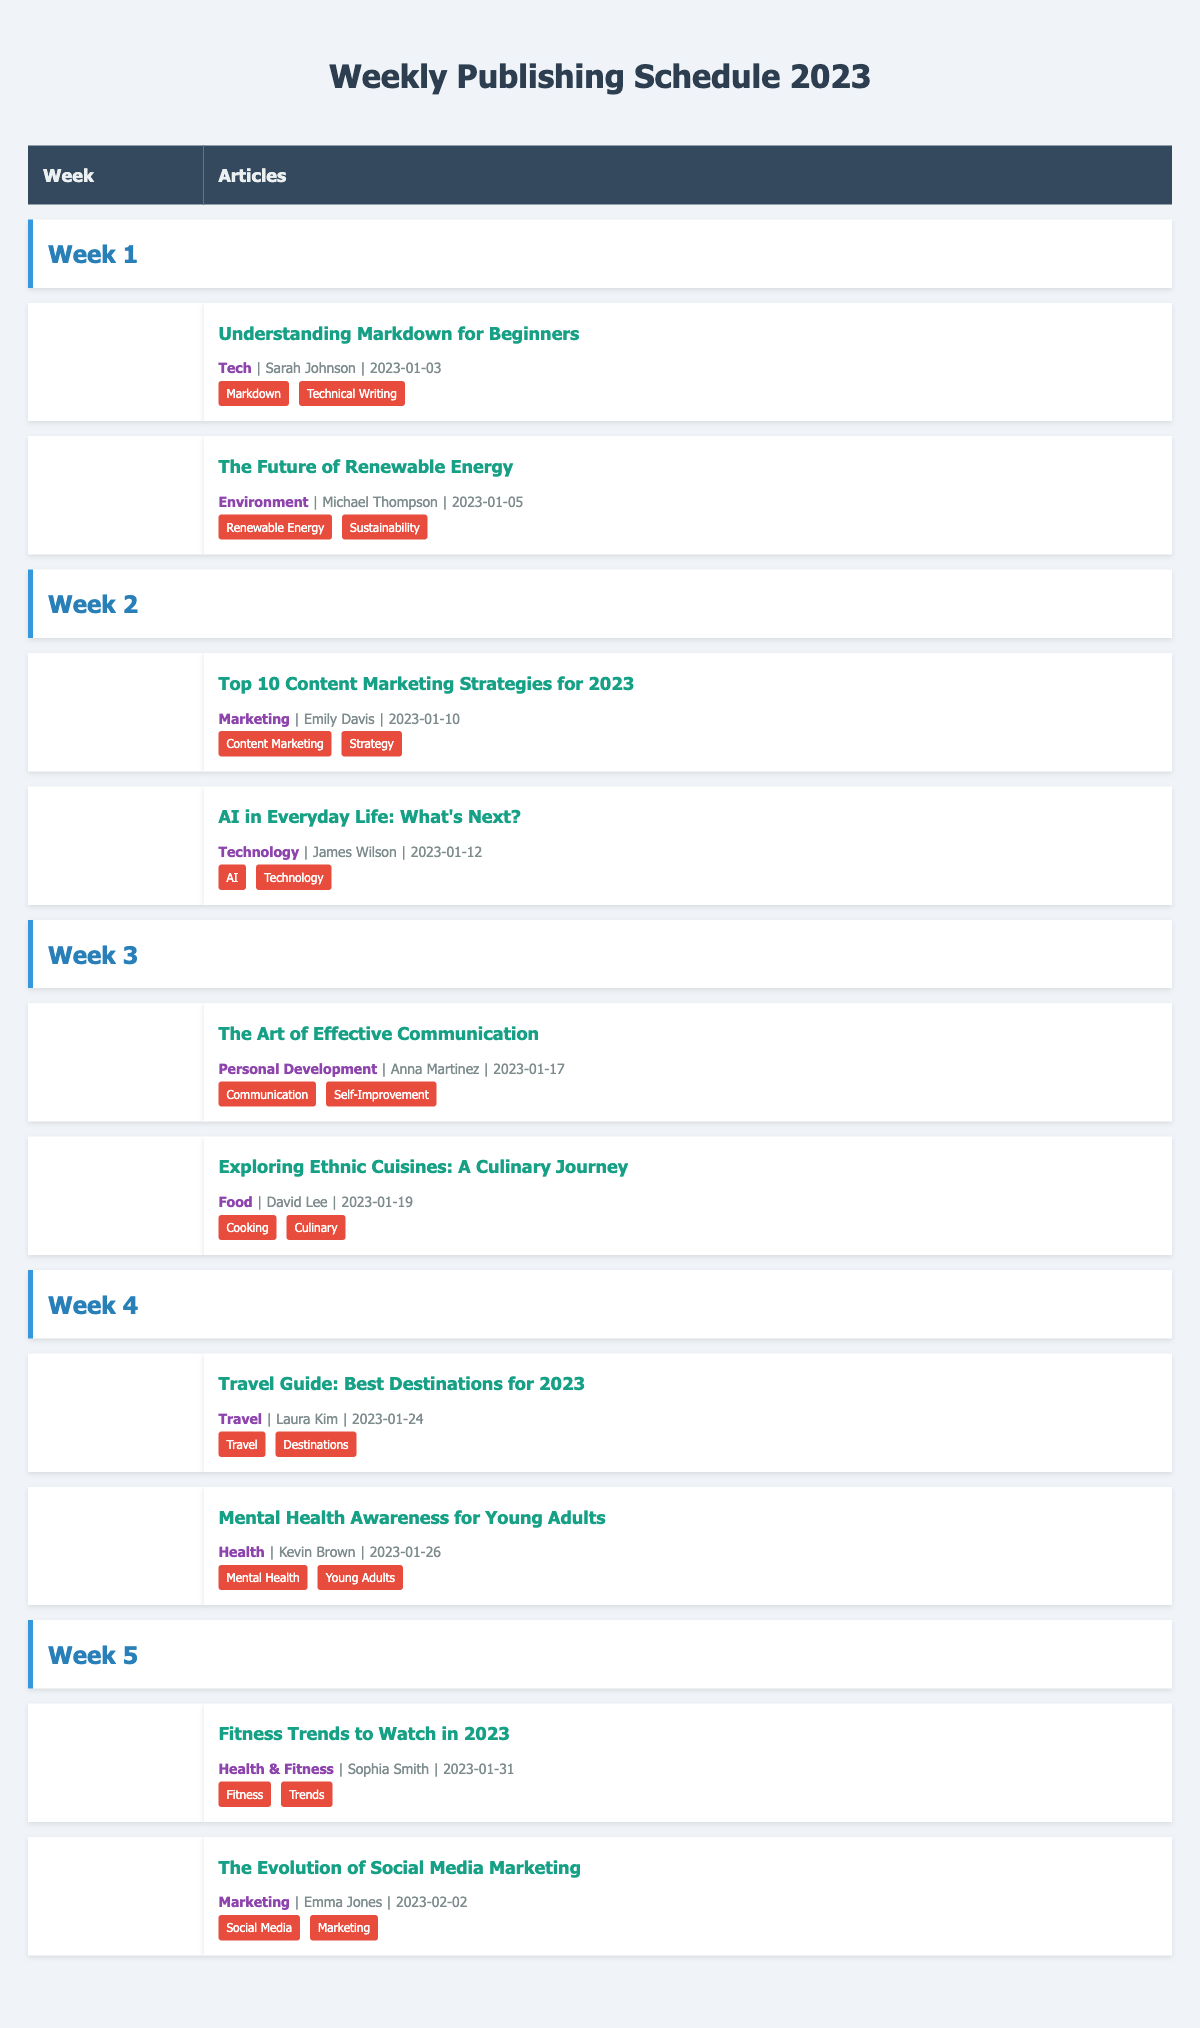What is the title of the article published in Week 1 that focuses on renewable energy? The article published in Week 1 about renewable energy is "The Future of Renewable Energy," authored by Michael Thompson on January 5, 2023.
Answer: The Future of Renewable Energy How many articles were published in Week 2? There were two articles published in Week 2: "Top 10 Content Marketing Strategies for 2023" and "AI in Everyday Life: What's Next?".
Answer: 2 Who is the author of the article on effective communication published in Week 3? The author of "The Art of Effective Communication," published in Week 3, is Anna Martinez.
Answer: Anna Martinez Which category does the article titled "Fitness Trends to Watch in 2023" belong to? The article "Fitness Trends to Watch in 2023" belongs to the "Health & Fitness" category, as indicated in the table.
Answer: Health & Fitness List all the tags associated with the article "AI in Everyday Life: What's Next?" According to the table, the tags associated with this article are "AI" and "Technology."
Answer: AI, Technology True or False: There are articles in the schedule that discuss food topics. Yes, there is an article titled "Exploring Ethnic Cuisines: A Culinary Journey" in Week 3, which discusses food topics.
Answer: True Which article has the same category as "Mental Health Awareness for Young Adults"? "Fitness Trends to Watch in 2023" also falls under the category of "Health." Both articles are available in the Health category, showing their relation.
Answer: Fitness Trends to Watch in 2023 What is the average publishing frequency of articles per week within the first 5 weeks? A total of 10 articles were published over 5 weeks, so the average is 10 articles divided by 5 weeks, which equals 2 articles per week.
Answer: 2 Who published the first article in Week 4? The first article in Week 4 is "Travel Guide: Best Destinations for 2023," published by Laura Kim on January 24, 2023.
Answer: Laura Kim Find the week with the least number of articles published and state how many. Weeks 1 to 5 each have 2 articles. Therefore, every week has the same number, so the least number is 2 articles per week across the board.
Answer: Each week has 2 articles 